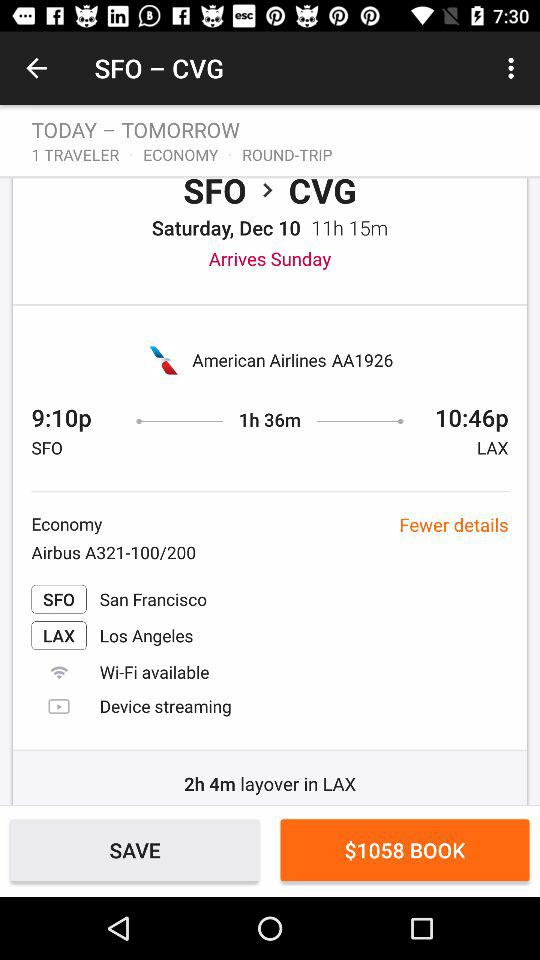What is the duration of the flight through the layover in LAX? The duration of the flight is 11 hours 15 minutes. 